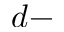<formula> <loc_0><loc_0><loc_500><loc_500>d -</formula> 